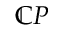<formula> <loc_0><loc_0><loc_500><loc_500>\mathbb { C } P</formula> 